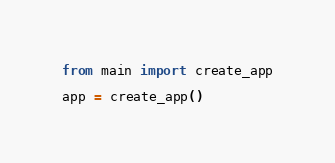<code> <loc_0><loc_0><loc_500><loc_500><_Python_>from main import create_app

app = create_app()
</code> 